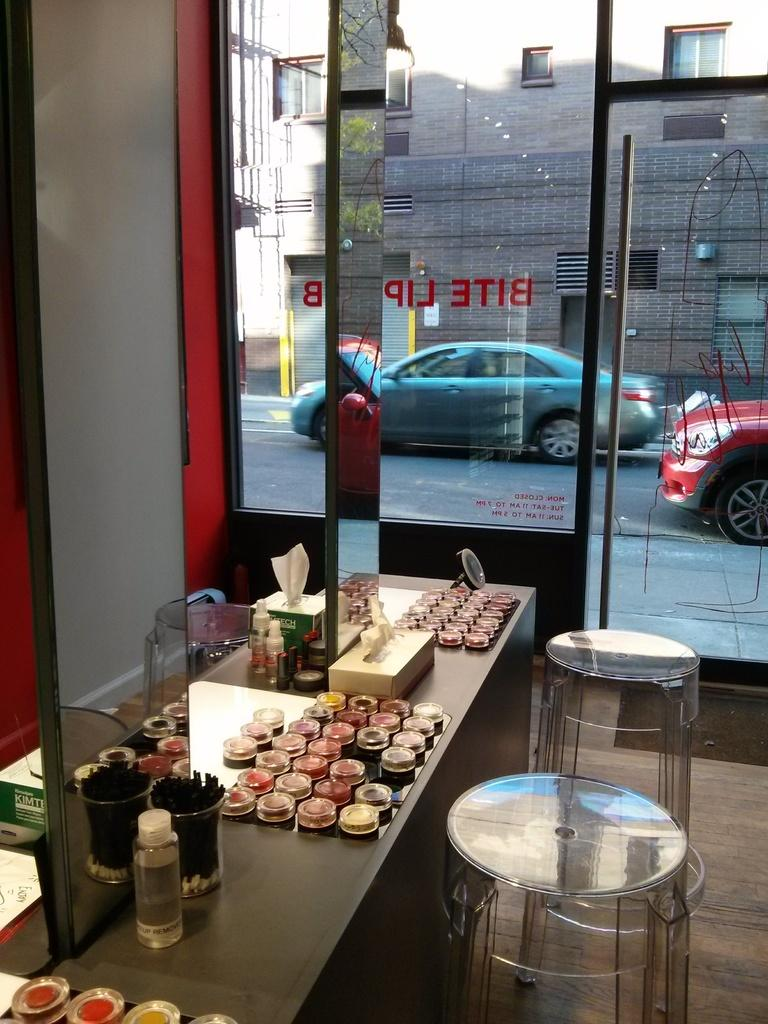What can be seen on the road in the image? There are vehicles on the road in the image. What type of structure is visible in the image? There is a building in the image. What feature of the building can be observed? The building has windows. What type of furniture is present in the image? There are stools in the image. What part of the room can be seen in the image? The floor is visible in the image. Can you describe the arch in the garden in the image? There is no arch or garden present in the image. What type of river can be seen flowing near the building in the image? There is no river visible in the image; it only features a building, vehicles on the road, and other objects. 